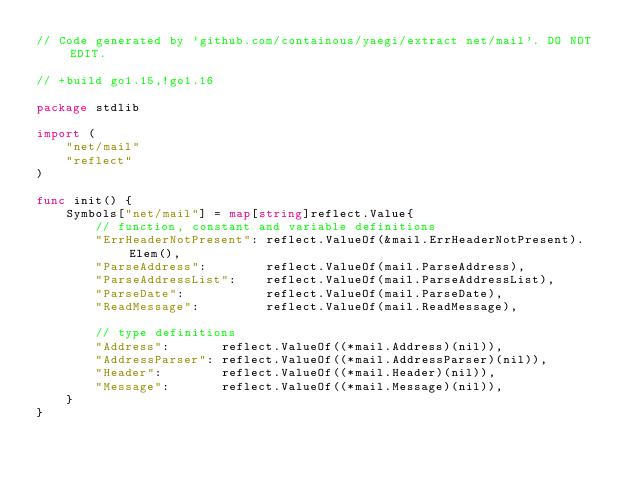Convert code to text. <code><loc_0><loc_0><loc_500><loc_500><_Go_>// Code generated by 'github.com/containous/yaegi/extract net/mail'. DO NOT EDIT.

// +build go1.15,!go1.16

package stdlib

import (
	"net/mail"
	"reflect"
)

func init() {
	Symbols["net/mail"] = map[string]reflect.Value{
		// function, constant and variable definitions
		"ErrHeaderNotPresent": reflect.ValueOf(&mail.ErrHeaderNotPresent).Elem(),
		"ParseAddress":        reflect.ValueOf(mail.ParseAddress),
		"ParseAddressList":    reflect.ValueOf(mail.ParseAddressList),
		"ParseDate":           reflect.ValueOf(mail.ParseDate),
		"ReadMessage":         reflect.ValueOf(mail.ReadMessage),

		// type definitions
		"Address":       reflect.ValueOf((*mail.Address)(nil)),
		"AddressParser": reflect.ValueOf((*mail.AddressParser)(nil)),
		"Header":        reflect.ValueOf((*mail.Header)(nil)),
		"Message":       reflect.ValueOf((*mail.Message)(nil)),
	}
}
</code> 